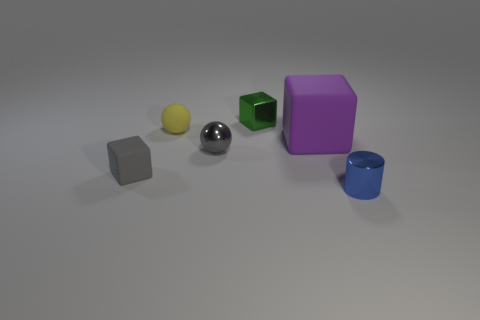There is a sphere that is to the left of the tiny gray thing on the right side of the small block that is in front of the large cube; what is it made of?
Your answer should be very brief. Rubber. What is the size of the matte thing that is both right of the gray cube and on the left side of the purple cube?
Your answer should be compact. Small. How many balls are blue metallic objects or purple matte things?
Ensure brevity in your answer.  0. What color is the metal sphere that is the same size as the gray rubber object?
Ensure brevity in your answer.  Gray. Is there anything else that is the same shape as the purple thing?
Keep it short and to the point. Yes. The small matte object that is the same shape as the big purple matte thing is what color?
Your answer should be compact. Gray. How many things are either small blue cylinders or spheres that are to the right of the rubber sphere?
Provide a succinct answer. 2. Are there fewer green cubes that are in front of the yellow thing than yellow objects?
Provide a succinct answer. Yes. There is a rubber block that is on the left side of the matte block to the right of the metal thing behind the small yellow sphere; what size is it?
Provide a short and direct response. Small. The thing that is behind the tiny gray metal ball and right of the green cube is what color?
Offer a very short reply. Purple. 